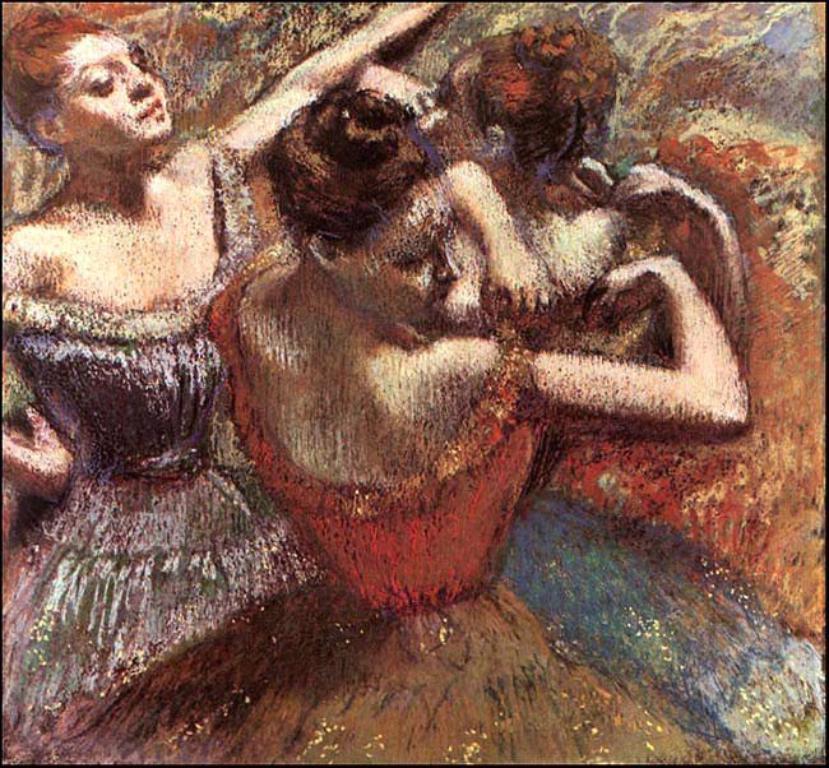Could you give a brief overview of what you see in this image? In this image there is a painting of girls dancing. 